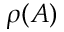Convert formula to latex. <formula><loc_0><loc_0><loc_500><loc_500>\rho ( A )</formula> 